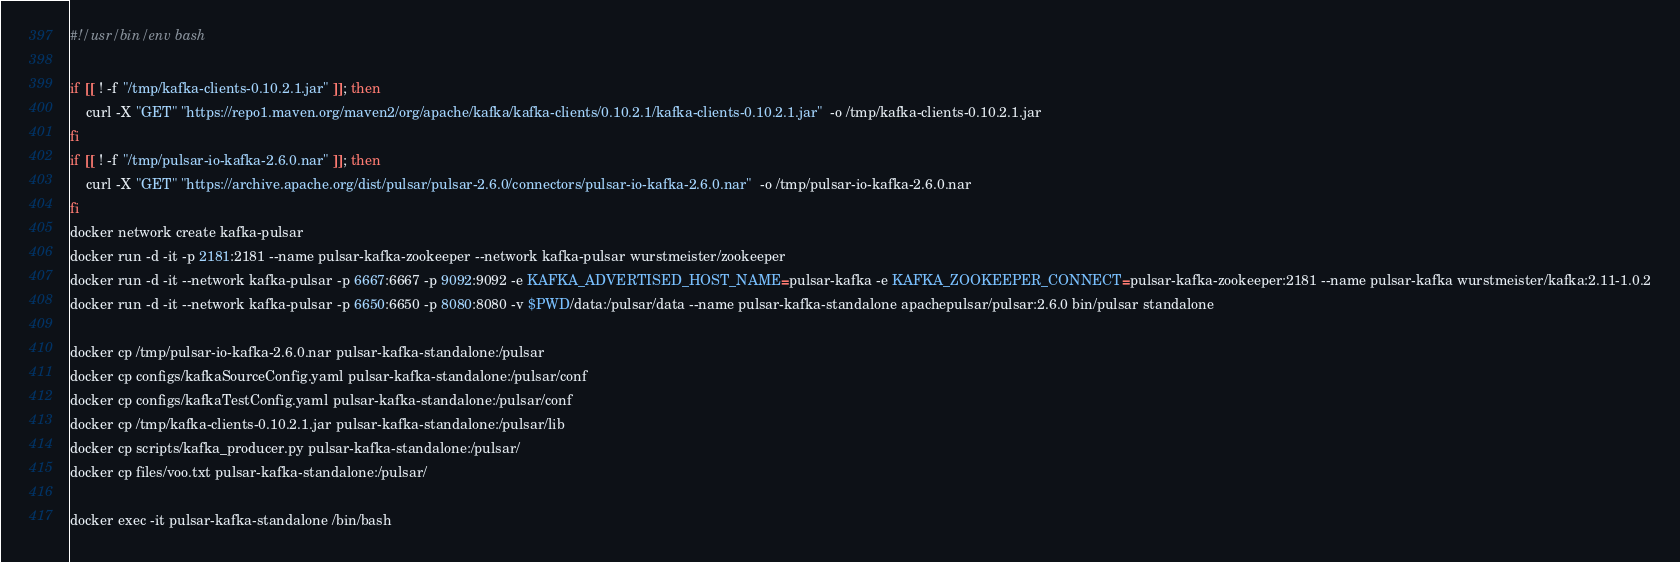Convert code to text. <code><loc_0><loc_0><loc_500><loc_500><_Bash_>#!/usr/bin/env bash

if [[ ! -f "/tmp/kafka-clients-0.10.2.1.jar" ]]; then
    curl -X "GET" "https://repo1.maven.org/maven2/org/apache/kafka/kafka-clients/0.10.2.1/kafka-clients-0.10.2.1.jar"  -o /tmp/kafka-clients-0.10.2.1.jar
fi
if [[ ! -f "/tmp/pulsar-io-kafka-2.6.0.nar" ]]; then
    curl -X "GET" "https://archive.apache.org/dist/pulsar/pulsar-2.6.0/connectors/pulsar-io-kafka-2.6.0.nar"  -o /tmp/pulsar-io-kafka-2.6.0.nar
fi
docker network create kafka-pulsar
docker run -d -it -p 2181:2181 --name pulsar-kafka-zookeeper --network kafka-pulsar wurstmeister/zookeeper
docker run -d -it --network kafka-pulsar -p 6667:6667 -p 9092:9092 -e KAFKA_ADVERTISED_HOST_NAME=pulsar-kafka -e KAFKA_ZOOKEEPER_CONNECT=pulsar-kafka-zookeeper:2181 --name pulsar-kafka wurstmeister/kafka:2.11-1.0.2
docker run -d -it --network kafka-pulsar -p 6650:6650 -p 8080:8080 -v $PWD/data:/pulsar/data --name pulsar-kafka-standalone apachepulsar/pulsar:2.6.0 bin/pulsar standalone

docker cp /tmp/pulsar-io-kafka-2.6.0.nar pulsar-kafka-standalone:/pulsar
docker cp configs/kafkaSourceConfig.yaml pulsar-kafka-standalone:/pulsar/conf
docker cp configs/kafkaTestConfig.yaml pulsar-kafka-standalone:/pulsar/conf
docker cp /tmp/kafka-clients-0.10.2.1.jar pulsar-kafka-standalone:/pulsar/lib
docker cp scripts/kafka_producer.py pulsar-kafka-standalone:/pulsar/
docker cp files/voo.txt pulsar-kafka-standalone:/pulsar/

docker exec -it pulsar-kafka-standalone /bin/bash
</code> 